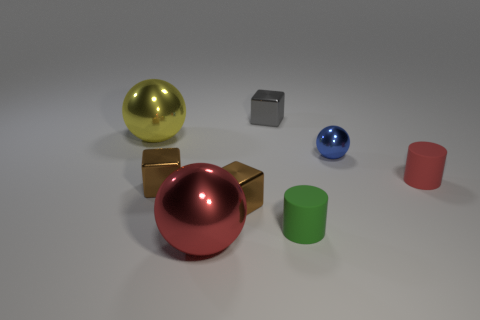There is a red rubber thing; does it have the same shape as the tiny matte object that is on the left side of the blue thing?
Your answer should be compact. Yes. There is a tiny object that is both behind the tiny red matte cylinder and left of the tiny blue object; what is its shape?
Provide a short and direct response. Cube. Are there the same number of small blue metallic balls on the left side of the large yellow ball and small blue metallic things?
Ensure brevity in your answer.  No. What number of things are blue spheres or spheres that are in front of the small sphere?
Offer a very short reply. 2. Are there any other small gray metal things of the same shape as the gray object?
Ensure brevity in your answer.  No. Is the number of small shiny balls that are right of the big red sphere the same as the number of large yellow metallic spheres that are to the right of the tiny blue metal object?
Keep it short and to the point. No. Are there any other things that have the same size as the blue thing?
Make the answer very short. Yes. What number of purple objects are cylinders or large metal balls?
Your answer should be very brief. 0. What number of blue things are the same size as the green cylinder?
Ensure brevity in your answer.  1. What is the color of the object that is both right of the yellow metal object and behind the blue ball?
Offer a terse response. Gray. 